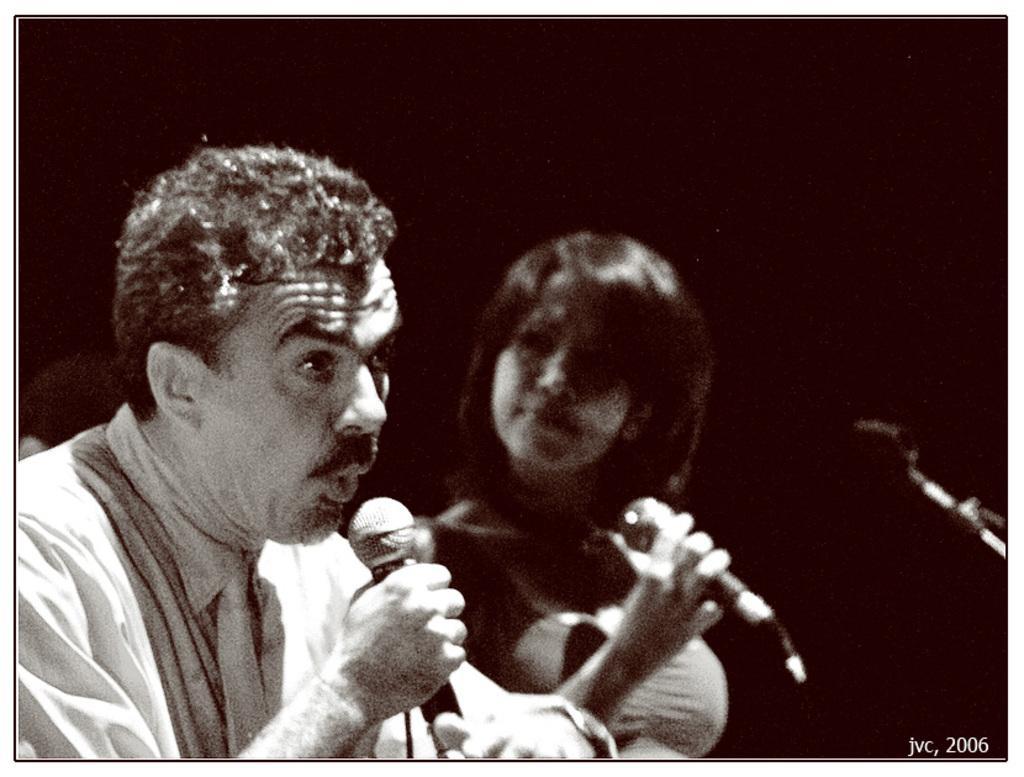In one or two sentences, can you explain what this image depicts? In this image, we can see a man and woman are holding microphones. It is a black and white image. On the right side, we can see a rod and watermark. Background we can see a dark view. 